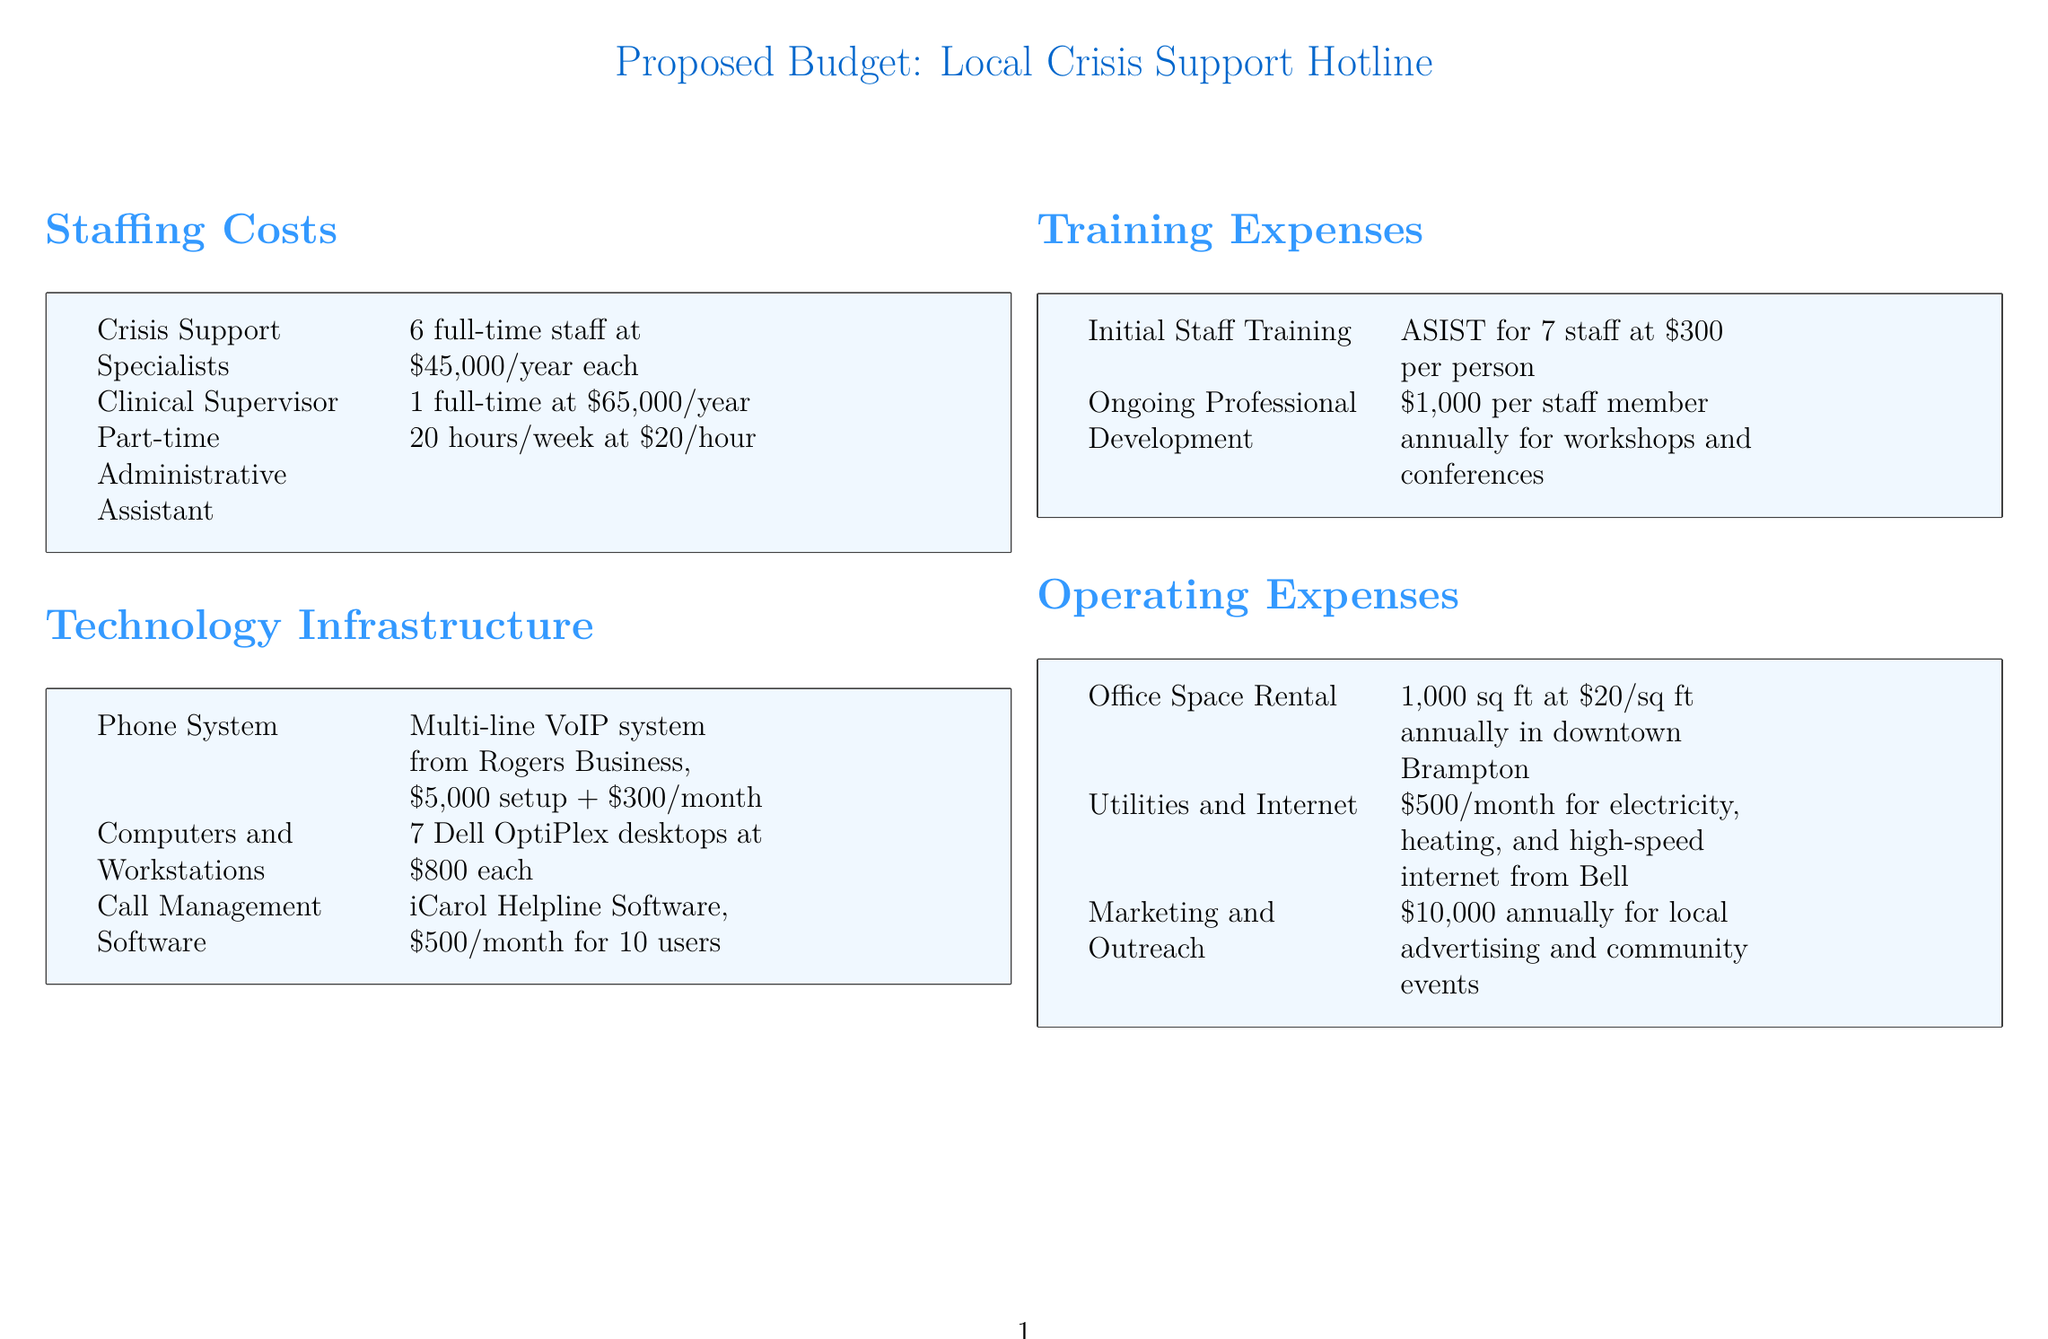What is the annual salary for a Crisis Support Specialist? The salary for each Crisis Support Specialist is listed as $45,000 per year.
Answer: $45,000 How many full-time staff are listed in the staffing costs? The document specifies 6 full-time Crisis Support Specialists and 1 Clinical Supervisor.
Answer: 7 What is the monthly cost of the call management software? The document states that the iCarol Helpline Software costs $500 per month for 10 users.
Answer: $500 How much is the initial training per staff member? The document indicates that the ASIST training costs $300 per person for initial training.
Answer: $300 What is the annual operating expense for marketing and outreach? The document lists the marketing and outreach expense as $10,000 annually.
Answer: $10,000 What is the total number of computers purchased? The document mentions that 7 Dell OptiPlex desktops are being bought.
Answer: 7 What is the total cost of the phone system setup? The setup cost for the multi-line VoIP system is specified as $5,000.
Answer: $5,000 What is the annual rent for the office space? The document states that the office space rental is $20 per square foot annually for 1,000 sq ft.
Answer: $20,000 What are the ongoing professional development costs per staff member? The ongoing professional development cost is indicated as $1,000 per staff member annually.
Answer: $1,000 